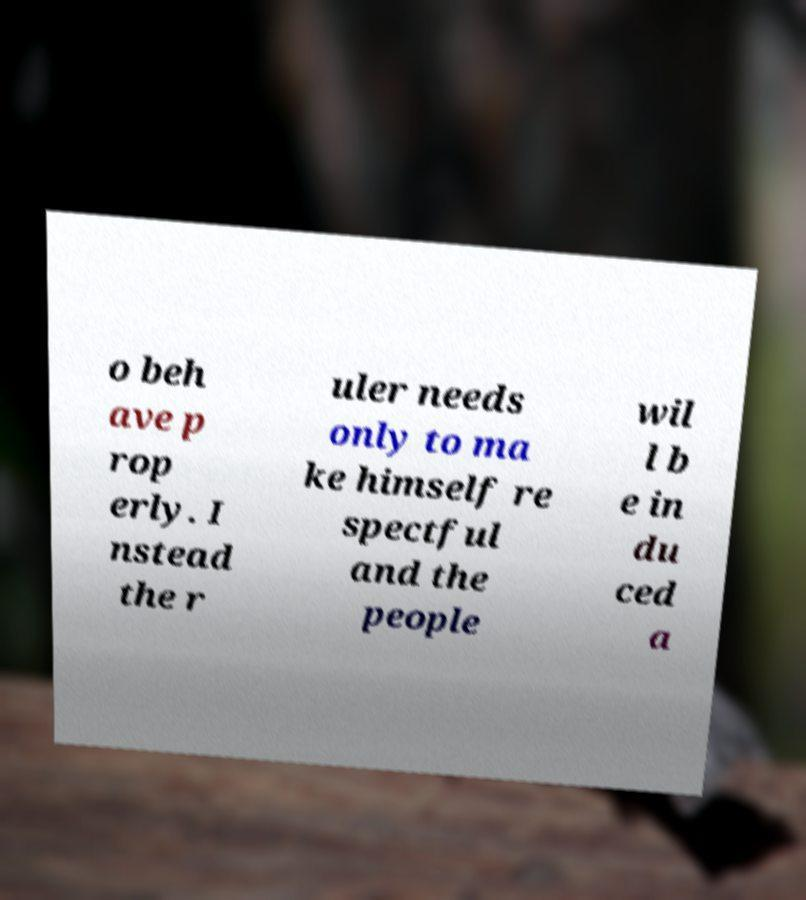There's text embedded in this image that I need extracted. Can you transcribe it verbatim? o beh ave p rop erly. I nstead the r uler needs only to ma ke himself re spectful and the people wil l b e in du ced a 